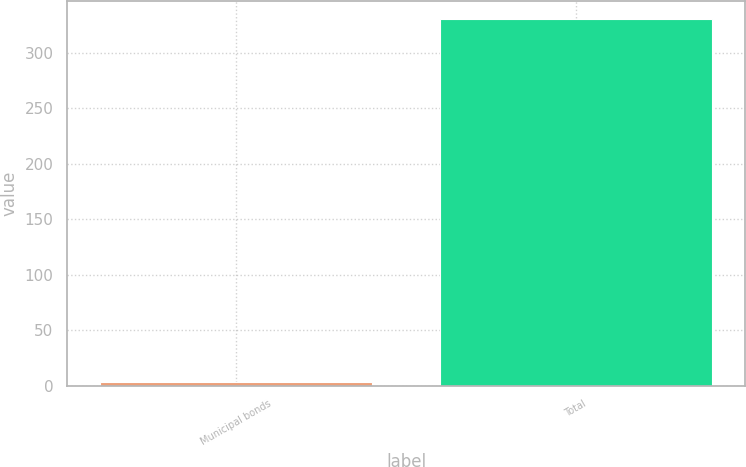Convert chart to OTSL. <chart><loc_0><loc_0><loc_500><loc_500><bar_chart><fcel>Municipal bonds<fcel>Total<nl><fcel>3<fcel>330<nl></chart> 